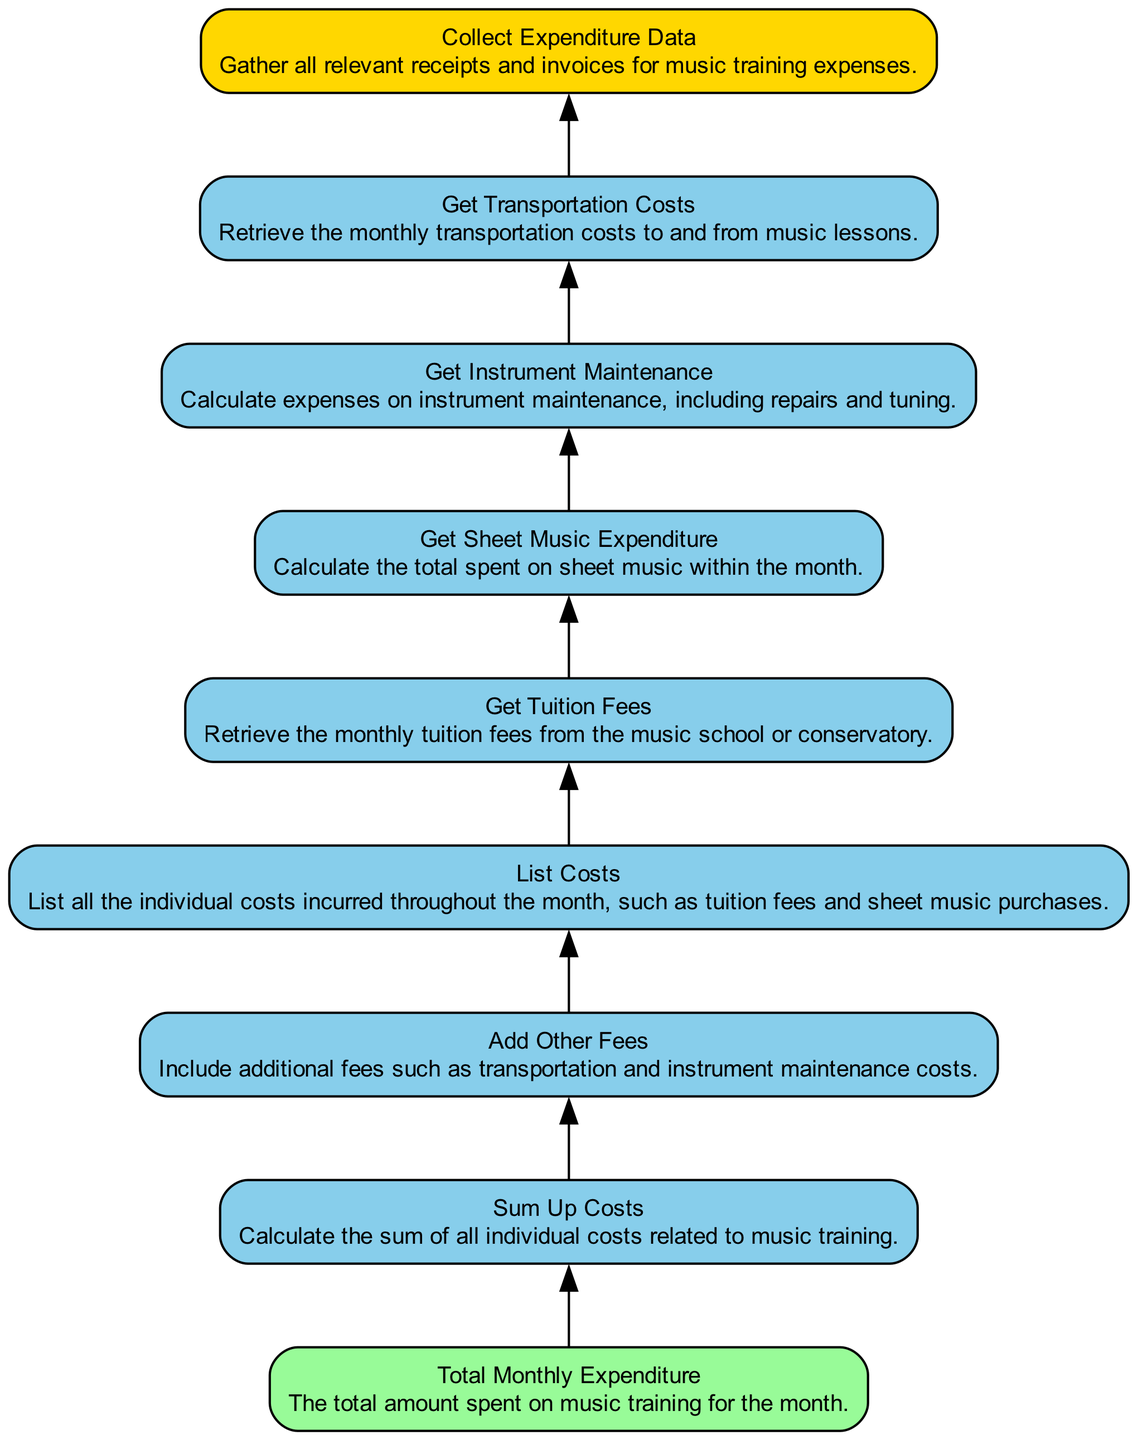What is the final output of the flowchart? The final output node is labeled "Total Monthly Expenditure," which indicates that this is the end goal of the process, where the total amount spent is summarized.
Answer: Total Monthly Expenditure How many operation nodes are present in the diagram? By counting the nodes with the type "operation," we find there are seven such nodes between the input and output nodes.
Answer: Seven Which node directly follows "Get Transportation Costs"? "Add Other Fees" is the node that comes directly after "Get Transportation Costs," indicating the next step in the expenditure analysis process.
Answer: Add Other Fees What type of node is "Collect Expenditure Data"? The node "Collect Expenditure Data" is an input node, as it involves gathering data necessary for later calculations in the flowchart.
Answer: Input What steps must be taken to compute the total expenditure? First, "Collect Expenditure Data" is conducted, followed by "Get Tuition Fees," "Get Sheet Music Expenditure," "Get Instrument Maintenance," and "Get Transportation Costs." Then, "List Costs" allows for compiling these expenses, which are finally summed in "Total Monthly Expenditure."
Answer: Collect Data, Get Fees, List Costs, Sum Expenditure What is the relationship between "Get Instrument Maintenance" and "Sum Up Costs"? "Get Instrument Maintenance" provides one of the individual costs that will be included in "Sum Up Costs," emphasizing its role in calculating the overall expenditure.
Answer: Individual Costs Contribution Which node is classified as an output? The node labeled "Total Monthly Expenditure" serves as the output, indicating the result of all previous operations and inputs.
Answer: Total Monthly Expenditure Which operation node is the last one before the output? The last operation node before reaching the output node is "Sum Up Costs," which aggregates all individual expense entries before final reporting.
Answer: Sum Up Costs 